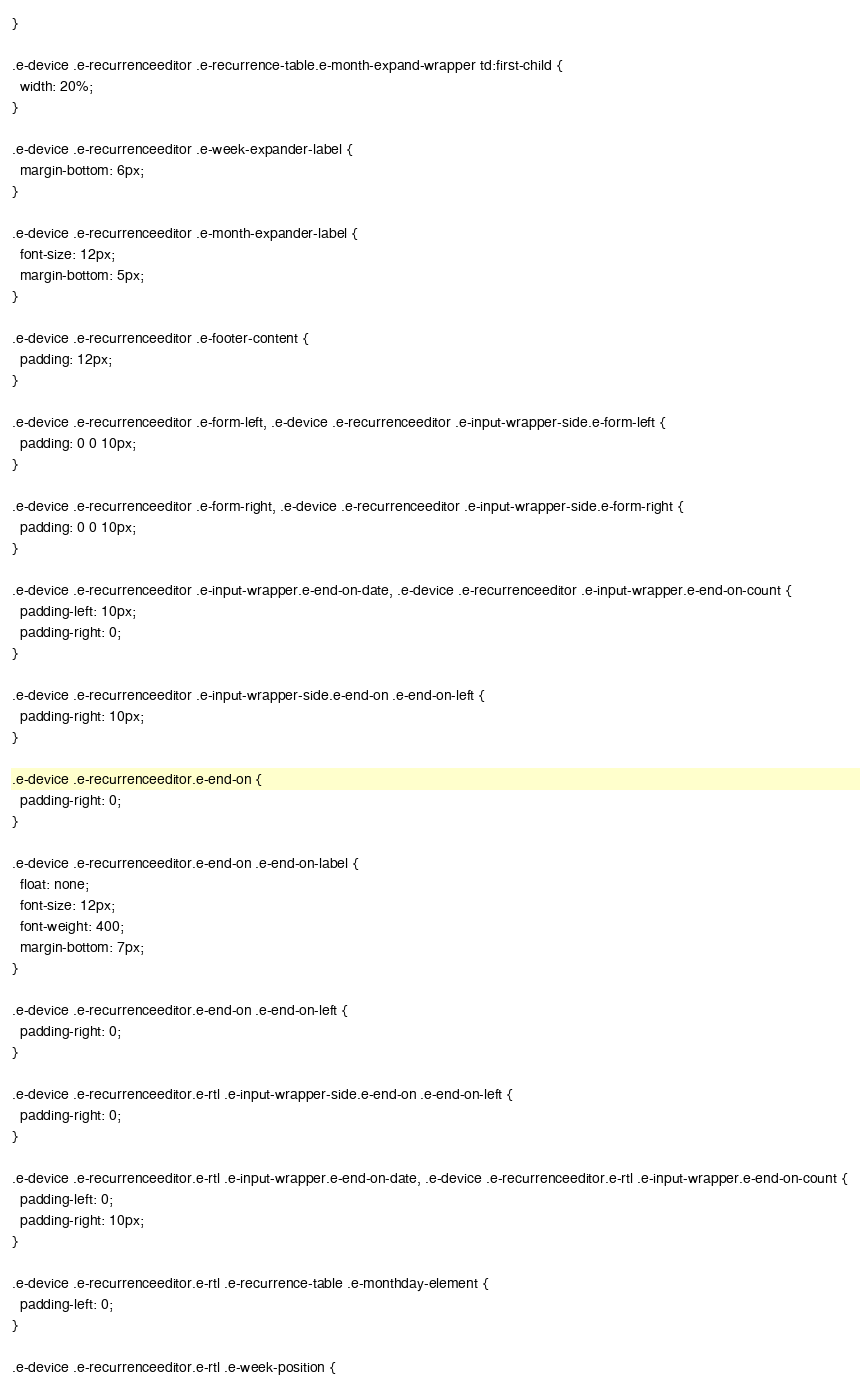<code> <loc_0><loc_0><loc_500><loc_500><_CSS_>}

.e-device .e-recurrenceeditor .e-recurrence-table.e-month-expand-wrapper td:first-child {
  width: 20%;
}

.e-device .e-recurrenceeditor .e-week-expander-label {
  margin-bottom: 6px;
}

.e-device .e-recurrenceeditor .e-month-expander-label {
  font-size: 12px;
  margin-bottom: 5px;
}

.e-device .e-recurrenceeditor .e-footer-content {
  padding: 12px;
}

.e-device .e-recurrenceeditor .e-form-left, .e-device .e-recurrenceeditor .e-input-wrapper-side.e-form-left {
  padding: 0 0 10px;
}

.e-device .e-recurrenceeditor .e-form-right, .e-device .e-recurrenceeditor .e-input-wrapper-side.e-form-right {
  padding: 0 0 10px;
}

.e-device .e-recurrenceeditor .e-input-wrapper.e-end-on-date, .e-device .e-recurrenceeditor .e-input-wrapper.e-end-on-count {
  padding-left: 10px;
  padding-right: 0;
}

.e-device .e-recurrenceeditor .e-input-wrapper-side.e-end-on .e-end-on-left {
  padding-right: 10px;
}

.e-device .e-recurrenceeditor.e-end-on {
  padding-right: 0;
}

.e-device .e-recurrenceeditor.e-end-on .e-end-on-label {
  float: none;
  font-size: 12px;
  font-weight: 400;
  margin-bottom: 7px;
}

.e-device .e-recurrenceeditor.e-end-on .e-end-on-left {
  padding-right: 0;
}

.e-device .e-recurrenceeditor.e-rtl .e-input-wrapper-side.e-end-on .e-end-on-left {
  padding-right: 0;
}

.e-device .e-recurrenceeditor.e-rtl .e-input-wrapper.e-end-on-date, .e-device .e-recurrenceeditor.e-rtl .e-input-wrapper.e-end-on-count {
  padding-left: 0;
  padding-right: 10px;
}

.e-device .e-recurrenceeditor.e-rtl .e-recurrence-table .e-monthday-element {
  padding-left: 0;
}

.e-device .e-recurrenceeditor.e-rtl .e-week-position {</code> 